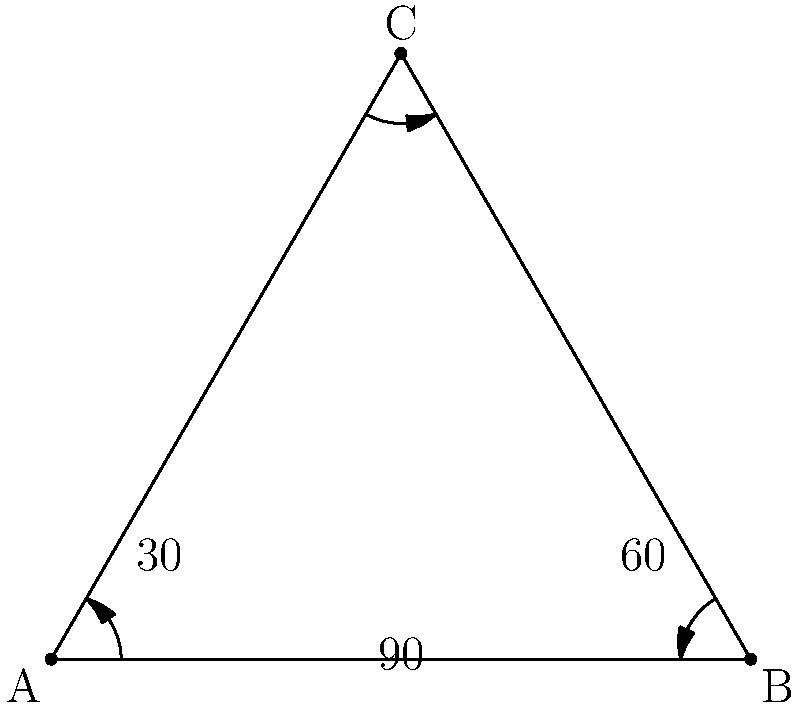In a car's rear-view mirror system, three mirrors are positioned to form an equilateral triangle. If the optimal viewing angle for each mirror is 60°, what is the total coverage area provided by all three mirrors combined? Let's approach this step-by-step:

1) In an equilateral triangle, each internal angle is 60°.

2) Each mirror provides a 60° viewing angle.

3) The total internal angle of a triangle is always 180°.

4) If we consider the mirrors to be positioned at the vertices of the triangle, each mirror's viewing angle exactly covers one of the triangle's internal angles.

5) This means that the three mirrors together provide complete coverage of the area within the triangle, plus some additional area outside the triangle.

6) To calculate the total coverage:
   - Coverage within the triangle: 180°
   - Additional coverage outside the triangle:
     * Left side: 30° (half of the 60° angle)
     * Right side: 30°
     * Top: 30°

7) Total additional coverage: $30° + 30° + 30° = 90°$

8) Total coverage: $180° + 90° = 270°$

Therefore, the total coverage area provided by all three mirrors combined is 270°.
Answer: 270° 